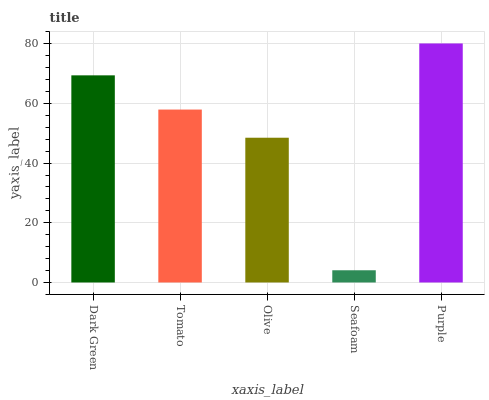Is Seafoam the minimum?
Answer yes or no. Yes. Is Purple the maximum?
Answer yes or no. Yes. Is Tomato the minimum?
Answer yes or no. No. Is Tomato the maximum?
Answer yes or no. No. Is Dark Green greater than Tomato?
Answer yes or no. Yes. Is Tomato less than Dark Green?
Answer yes or no. Yes. Is Tomato greater than Dark Green?
Answer yes or no. No. Is Dark Green less than Tomato?
Answer yes or no. No. Is Tomato the high median?
Answer yes or no. Yes. Is Tomato the low median?
Answer yes or no. Yes. Is Olive the high median?
Answer yes or no. No. Is Dark Green the low median?
Answer yes or no. No. 